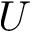Convert formula to latex. <formula><loc_0><loc_0><loc_500><loc_500>U</formula> 